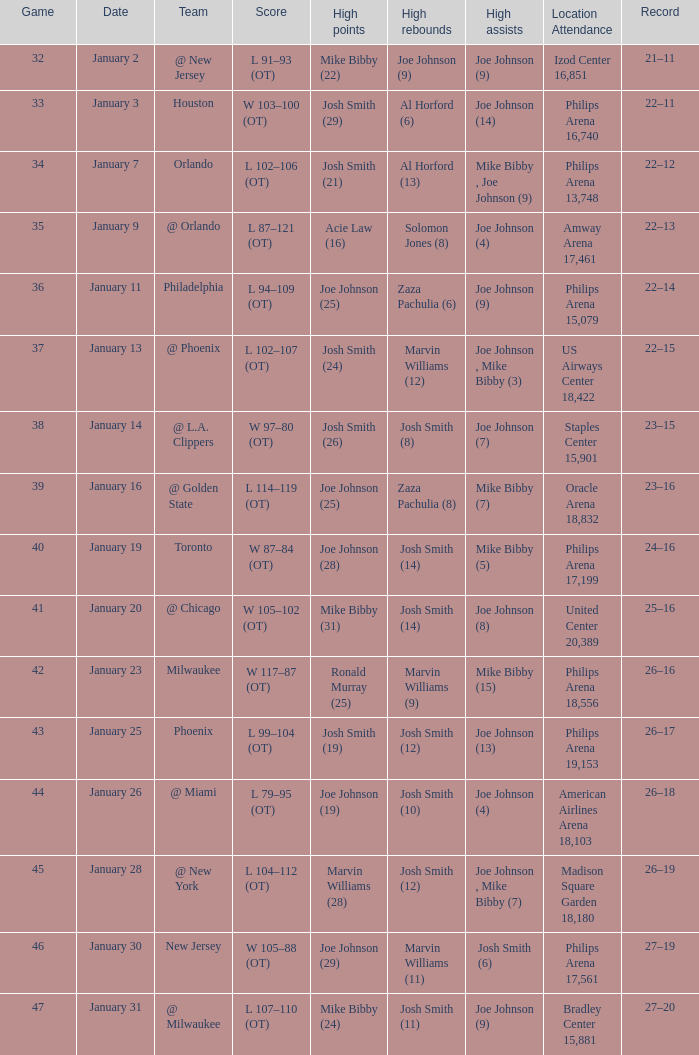I'm looking to parse the entire table for insights. Could you assist me with that? {'header': ['Game', 'Date', 'Team', 'Score', 'High points', 'High rebounds', 'High assists', 'Location Attendance', 'Record'], 'rows': [['32', 'January 2', '@ New Jersey', 'L 91–93 (OT)', 'Mike Bibby (22)', 'Joe Johnson (9)', 'Joe Johnson (9)', 'Izod Center 16,851', '21–11'], ['33', 'January 3', 'Houston', 'W 103–100 (OT)', 'Josh Smith (29)', 'Al Horford (6)', 'Joe Johnson (14)', 'Philips Arena 16,740', '22–11'], ['34', 'January 7', 'Orlando', 'L 102–106 (OT)', 'Josh Smith (21)', 'Al Horford (13)', 'Mike Bibby , Joe Johnson (9)', 'Philips Arena 13,748', '22–12'], ['35', 'January 9', '@ Orlando', 'L 87–121 (OT)', 'Acie Law (16)', 'Solomon Jones (8)', 'Joe Johnson (4)', 'Amway Arena 17,461', '22–13'], ['36', 'January 11', 'Philadelphia', 'L 94–109 (OT)', 'Joe Johnson (25)', 'Zaza Pachulia (6)', 'Joe Johnson (9)', 'Philips Arena 15,079', '22–14'], ['37', 'January 13', '@ Phoenix', 'L 102–107 (OT)', 'Josh Smith (24)', 'Marvin Williams (12)', 'Joe Johnson , Mike Bibby (3)', 'US Airways Center 18,422', '22–15'], ['38', 'January 14', '@ L.A. Clippers', 'W 97–80 (OT)', 'Josh Smith (26)', 'Josh Smith (8)', 'Joe Johnson (7)', 'Staples Center 15,901', '23–15'], ['39', 'January 16', '@ Golden State', 'L 114–119 (OT)', 'Joe Johnson (25)', 'Zaza Pachulia (8)', 'Mike Bibby (7)', 'Oracle Arena 18,832', '23–16'], ['40', 'January 19', 'Toronto', 'W 87–84 (OT)', 'Joe Johnson (28)', 'Josh Smith (14)', 'Mike Bibby (5)', 'Philips Arena 17,199', '24–16'], ['41', 'January 20', '@ Chicago', 'W 105–102 (OT)', 'Mike Bibby (31)', 'Josh Smith (14)', 'Joe Johnson (8)', 'United Center 20,389', '25–16'], ['42', 'January 23', 'Milwaukee', 'W 117–87 (OT)', 'Ronald Murray (25)', 'Marvin Williams (9)', 'Mike Bibby (15)', 'Philips Arena 18,556', '26–16'], ['43', 'January 25', 'Phoenix', 'L 99–104 (OT)', 'Josh Smith (19)', 'Josh Smith (12)', 'Joe Johnson (13)', 'Philips Arena 19,153', '26–17'], ['44', 'January 26', '@ Miami', 'L 79–95 (OT)', 'Joe Johnson (19)', 'Josh Smith (10)', 'Joe Johnson (4)', 'American Airlines Arena 18,103', '26–18'], ['45', 'January 28', '@ New York', 'L 104–112 (OT)', 'Marvin Williams (28)', 'Josh Smith (12)', 'Joe Johnson , Mike Bibby (7)', 'Madison Square Garden 18,180', '26–19'], ['46', 'January 30', 'New Jersey', 'W 105–88 (OT)', 'Joe Johnson (29)', 'Marvin Williams (11)', 'Josh Smith (6)', 'Philips Arena 17,561', '27–19'], ['47', 'January 31', '@ Milwaukee', 'L 107–110 (OT)', 'Mike Bibby (24)', 'Josh Smith (11)', 'Joe Johnson (9)', 'Bradley Center 15,881', '27–20']]} What was the record after game 37? 22–15. 